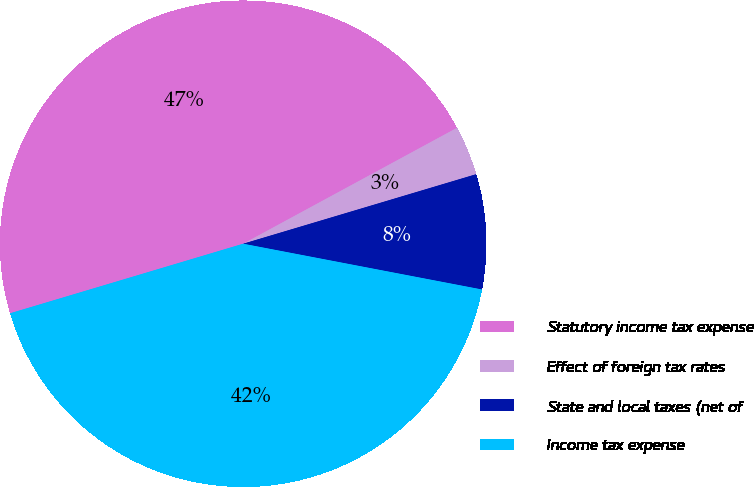<chart> <loc_0><loc_0><loc_500><loc_500><pie_chart><fcel>Statutory income tax expense<fcel>Effect of foreign tax rates<fcel>State and local taxes (net of<fcel>Income tax expense<nl><fcel>46.71%<fcel>3.29%<fcel>7.63%<fcel>42.37%<nl></chart> 